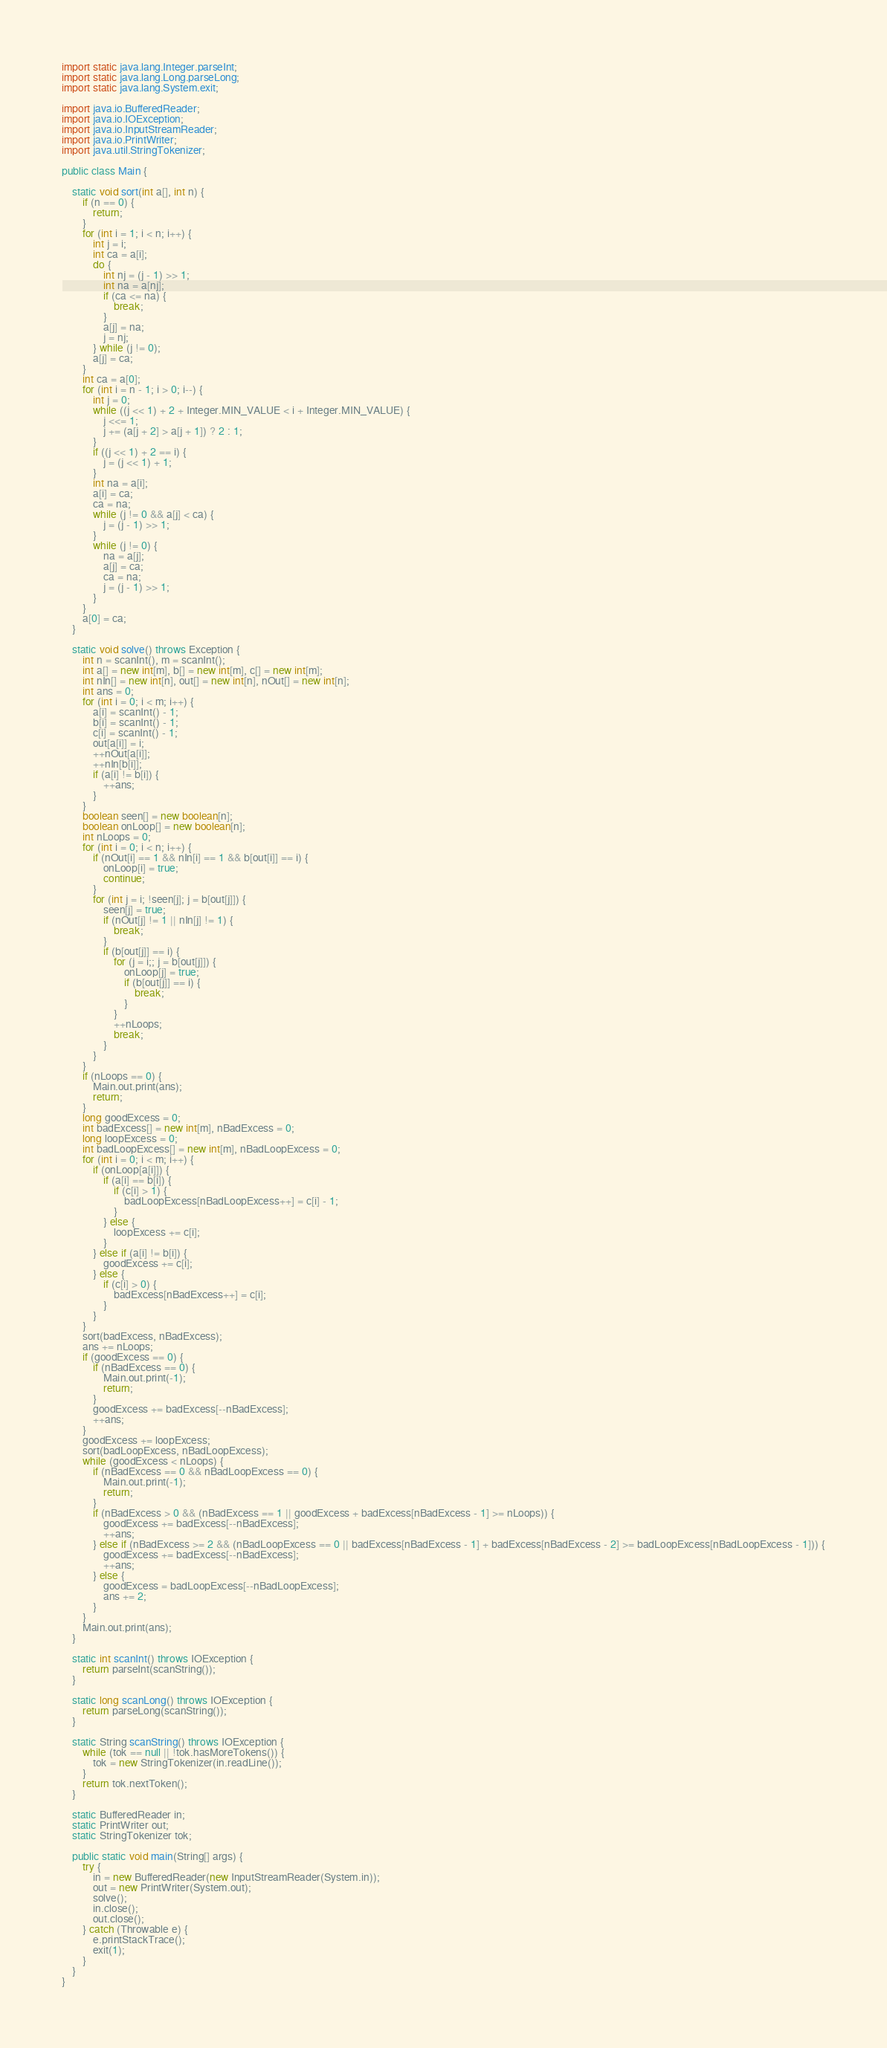<code> <loc_0><loc_0><loc_500><loc_500><_Java_>import static java.lang.Integer.parseInt;
import static java.lang.Long.parseLong;
import static java.lang.System.exit;

import java.io.BufferedReader;
import java.io.IOException;
import java.io.InputStreamReader;
import java.io.PrintWriter;
import java.util.StringTokenizer;

public class Main {

	static void sort(int a[], int n) {
		if (n == 0) {
			return;
		}
		for (int i = 1; i < n; i++) {
			int j = i;
			int ca = a[i];
			do {
				int nj = (j - 1) >> 1;
				int na = a[nj];
				if (ca <= na) {
					break;
				}
				a[j] = na;
				j = nj;
			} while (j != 0);
			a[j] = ca;
		}
		int ca = a[0];
		for (int i = n - 1; i > 0; i--) {
			int j = 0;
			while ((j << 1) + 2 + Integer.MIN_VALUE < i + Integer.MIN_VALUE) {
				j <<= 1;
				j += (a[j + 2] > a[j + 1]) ? 2 : 1;
			}
			if ((j << 1) + 2 == i) {
				j = (j << 1) + 1;
			}
			int na = a[i];
			a[i] = ca;
			ca = na;
			while (j != 0 && a[j] < ca) {
				j = (j - 1) >> 1;
			}
			while (j != 0) {
				na = a[j];
				a[j] = ca;
				ca = na;
				j = (j - 1) >> 1;
			}
		}
		a[0] = ca;
	}

	static void solve() throws Exception {
		int n = scanInt(), m = scanInt();
		int a[] = new int[m], b[] = new int[m], c[] = new int[m];
		int nIn[] = new int[n], out[] = new int[n], nOut[] = new int[n];
		int ans = 0;
		for (int i = 0; i < m; i++) {
			a[i] = scanInt() - 1;
			b[i] = scanInt() - 1;
			c[i] = scanInt() - 1;
			out[a[i]] = i;
			++nOut[a[i]];
			++nIn[b[i]];
			if (a[i] != b[i]) {
				++ans;
			}
		}
		boolean seen[] = new boolean[n];
		boolean onLoop[] = new boolean[n];
		int nLoops = 0;
		for (int i = 0; i < n; i++) {
			if (nOut[i] == 1 && nIn[i] == 1 && b[out[i]] == i) {
				onLoop[i] = true;
				continue;
			}
			for (int j = i; !seen[j]; j = b[out[j]]) {
				seen[j] = true;
				if (nOut[j] != 1 || nIn[j] != 1) {
					break;
				}
				if (b[out[j]] == i) {
					for (j = i;; j = b[out[j]]) {
						onLoop[j] = true;
						if (b[out[j]] == i) {
							break;
						}
					}
					++nLoops;
					break;
				}
			}
		}
		if (nLoops == 0) {
			Main.out.print(ans);
			return;
		}
		long goodExcess = 0;
		int badExcess[] = new int[m], nBadExcess = 0;
		long loopExcess = 0;
		int badLoopExcess[] = new int[m], nBadLoopExcess = 0;
		for (int i = 0; i < m; i++) {
			if (onLoop[a[i]]) {
				if (a[i] == b[i]) {
					if (c[i] > 1) {
						badLoopExcess[nBadLoopExcess++] = c[i] - 1;
					}
				} else {
					loopExcess += c[i];
				}
			} else if (a[i] != b[i]) {
				goodExcess += c[i];
			} else {
				if (c[i] > 0) {
					badExcess[nBadExcess++] = c[i];
				}
			}
		}
		sort(badExcess, nBadExcess);
		ans += nLoops;
		if (goodExcess == 0) {
			if (nBadExcess == 0) {
				Main.out.print(-1);
				return;
			}
			goodExcess += badExcess[--nBadExcess];
			++ans;
		}
		goodExcess += loopExcess;
		sort(badLoopExcess, nBadLoopExcess);
		while (goodExcess < nLoops) {
			if (nBadExcess == 0 && nBadLoopExcess == 0) {
				Main.out.print(-1);
				return;
			}
			if (nBadExcess > 0 && (nBadExcess == 1 || goodExcess + badExcess[nBadExcess - 1] >= nLoops)) {
				goodExcess += badExcess[--nBadExcess];
				++ans;
			} else if (nBadExcess >= 2 && (nBadLoopExcess == 0 || badExcess[nBadExcess - 1] + badExcess[nBadExcess - 2] >= badLoopExcess[nBadLoopExcess - 1])) {
				goodExcess += badExcess[--nBadExcess];
				++ans;
			} else {
				goodExcess = badLoopExcess[--nBadLoopExcess];
				ans += 2;
			}
		}
		Main.out.print(ans);
	}

	static int scanInt() throws IOException {
		return parseInt(scanString());
	}

	static long scanLong() throws IOException {
		return parseLong(scanString());
	}

	static String scanString() throws IOException {
		while (tok == null || !tok.hasMoreTokens()) {
			tok = new StringTokenizer(in.readLine());
		}
		return tok.nextToken();
	}

	static BufferedReader in;
	static PrintWriter out;
	static StringTokenizer tok;

	public static void main(String[] args) {
		try {
			in = new BufferedReader(new InputStreamReader(System.in));
			out = new PrintWriter(System.out);
			solve();
			in.close();
			out.close();
		} catch (Throwable e) {
			e.printStackTrace();
			exit(1);
		}
	}
}</code> 